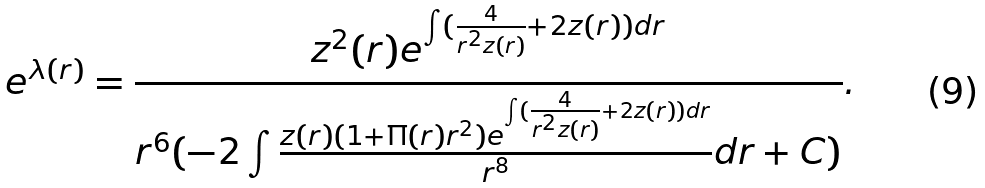Convert formula to latex. <formula><loc_0><loc_0><loc_500><loc_500>e ^ { \lambda ( r ) } = \frac { z ^ { 2 } ( r ) e ^ { \int ( \frac { 4 } { r ^ { 2 } z ( r ) } + 2 z ( r ) ) d r } } { r ^ { 6 } ( - 2 \int \frac { z ( r ) ( 1 + \Pi ( r ) r ^ { 2 } ) e ^ { \int ( \frac { 4 } { r ^ { 2 } z ( r ) } + 2 z ( r ) ) d r } } { r ^ { 8 } } d r + C ) } .</formula> 